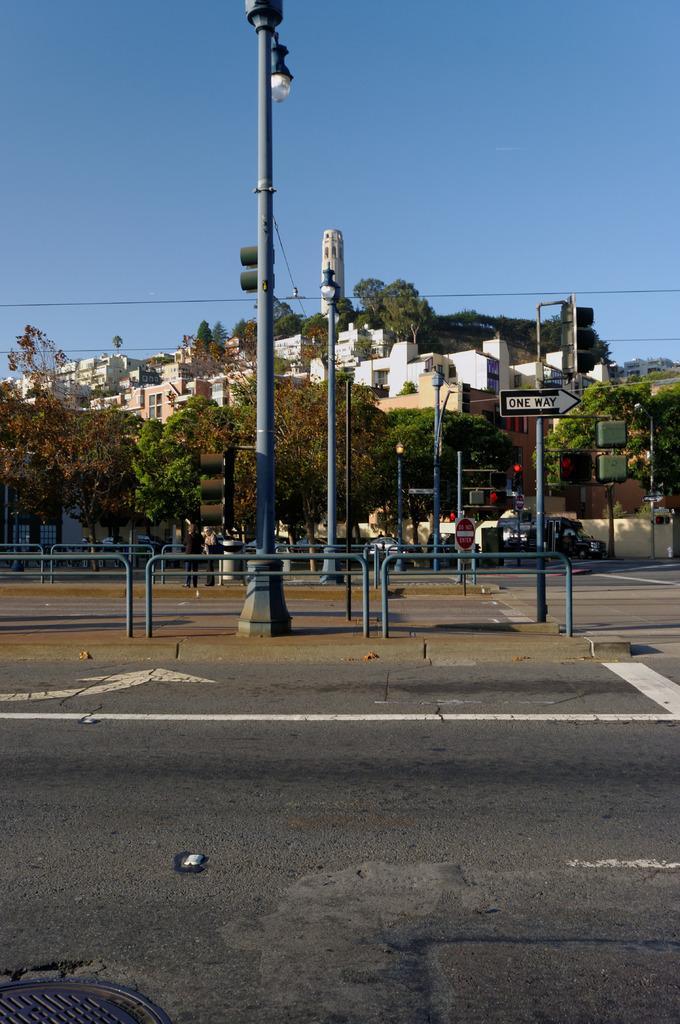Describe this image in one or two sentences. In this picture there are poles in the foreground and there are lights and there is a board on the poles. There is a person standing behind the podium and there are vehicles on the road. At the back there are buildings, trees. At the top there is sky. At the bottom there is a manhole on the road. 